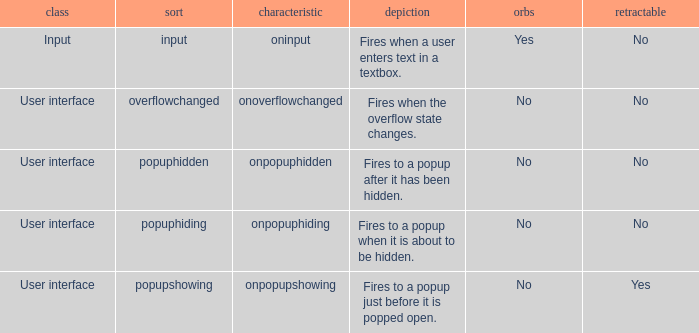What's the cancelable with bubbles being yes No. 